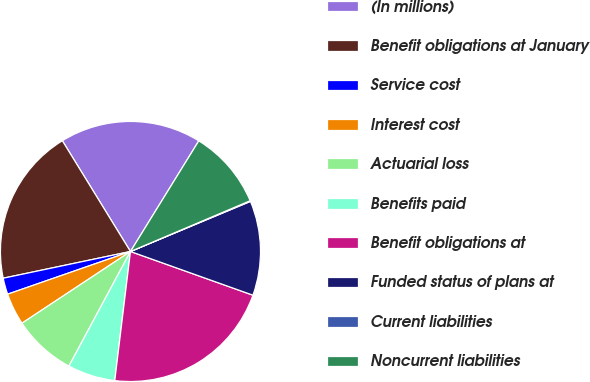Convert chart. <chart><loc_0><loc_0><loc_500><loc_500><pie_chart><fcel>(In millions)<fcel>Benefit obligations at January<fcel>Service cost<fcel>Interest cost<fcel>Actuarial loss<fcel>Benefits paid<fcel>Benefit obligations at<fcel>Funded status of plans at<fcel>Current liabilities<fcel>Noncurrent liabilities<nl><fcel>17.58%<fcel>19.52%<fcel>2.03%<fcel>3.97%<fcel>7.86%<fcel>5.92%<fcel>21.47%<fcel>11.75%<fcel>0.09%<fcel>9.81%<nl></chart> 